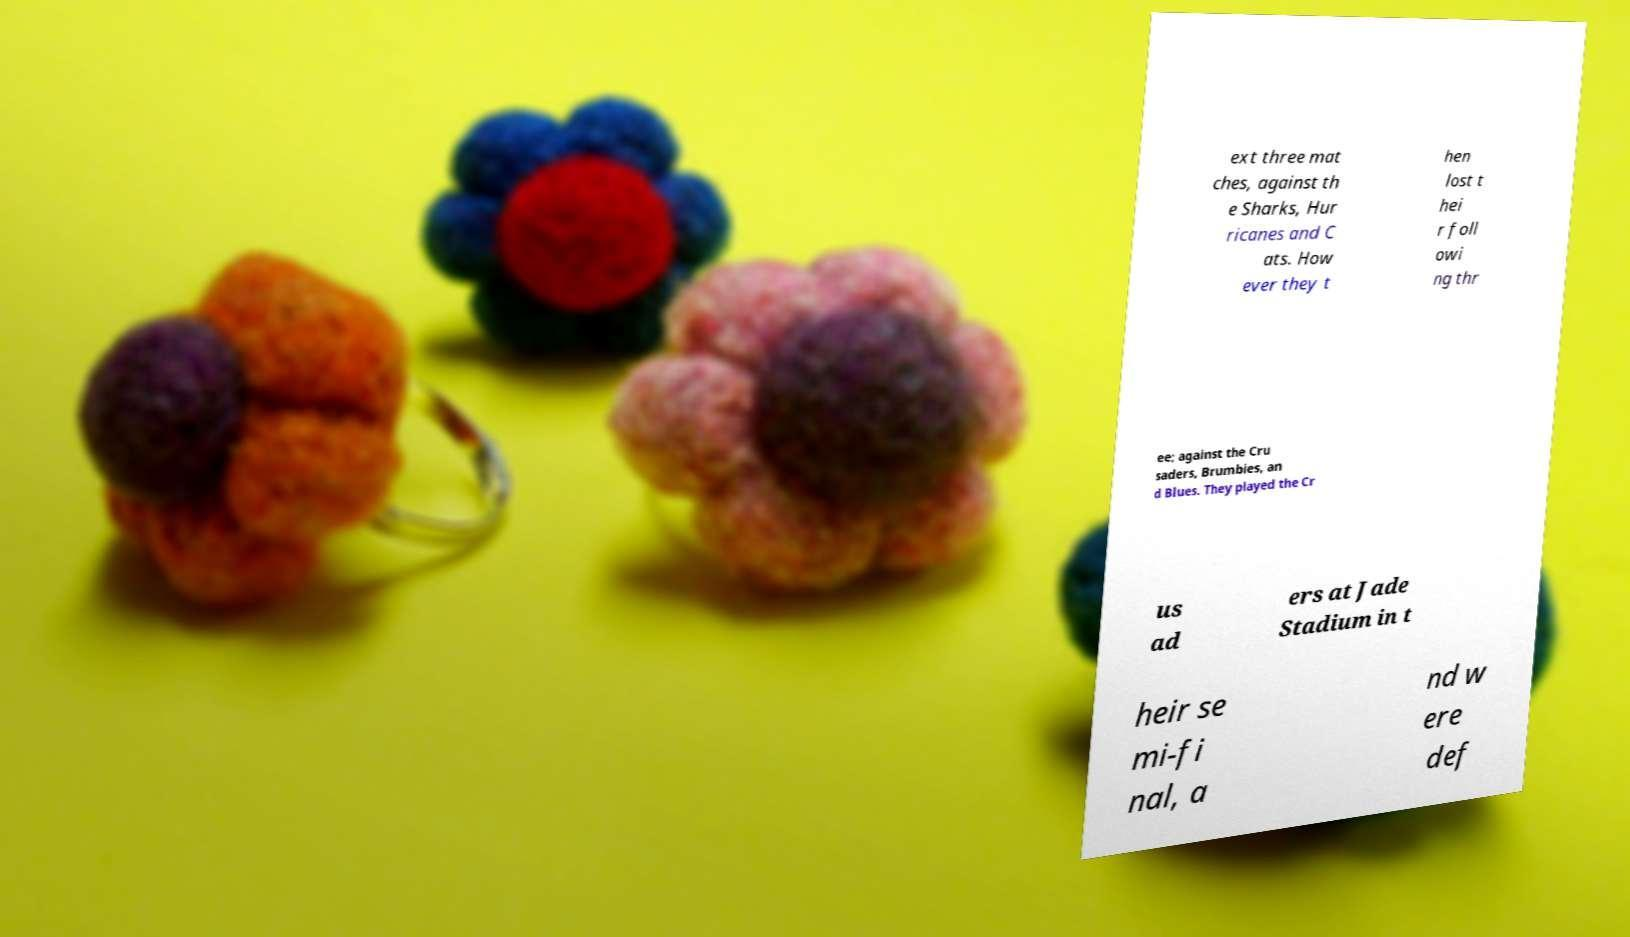Please identify and transcribe the text found in this image. ext three mat ches, against th e Sharks, Hur ricanes and C ats. How ever they t hen lost t hei r foll owi ng thr ee; against the Cru saders, Brumbies, an d Blues. They played the Cr us ad ers at Jade Stadium in t heir se mi-fi nal, a nd w ere def 